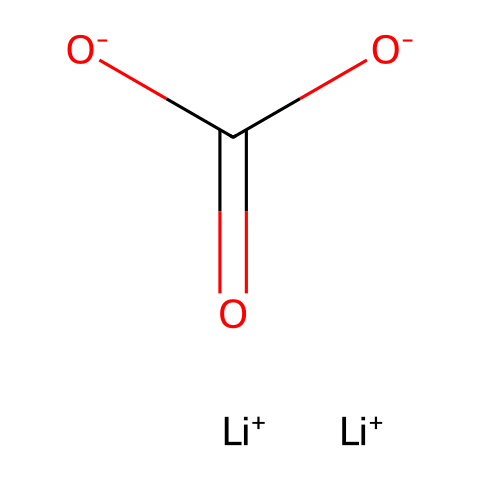What is the molecular formula of lithium carbonate? The molecular formula can be derived from the SMILES representation, which shows two lithium atoms (Li), one carbon atom (C), and three oxygen atoms (O). This corresponds to the molecular formula Li2CO3.
Answer: Li2CO3 How many lithium ions are present in the chemical structure? By examining the SMILES representation, we see two lithium ions (Li+) indicated before the carbonate group, thus confirming the presence of two lithium ions.
Answer: 2 What type of bond links the lithium ions to the carbonate ion? The lithium ions (Li+) are connected to the carbonate ion through ionic bonds, as lithium is a metal and the carbonate ion carries a net negative charge.
Answer: ionic Which part of this chemical structure indicates its ionic nature? The presence of Li+ ions and the negatively charged carbonate (O-) within the structure indicates that it is ionic, as ionic compounds are composed of positively and negatively charged ions.
Answer: Li+ and O- What does the notation (C(=O)[O-]) represent in the chemical structure? The notation indicates that the carbon atom (C) is bonded to an oxygen atom with a double bond (indicated by '=') and is also bonded to another oxygen atom that carries a negative charge (O-), representing the carbonate ion.
Answer: carbonate ion How does the presence of lithium ions affect the solubility of lithium carbonate? The presence of lithium ions generally enhances the solubility of lithium carbonate in water due to the ionic interactions with water molecules, making it more soluble compared to other types of salts.
Answer: increases solubility 